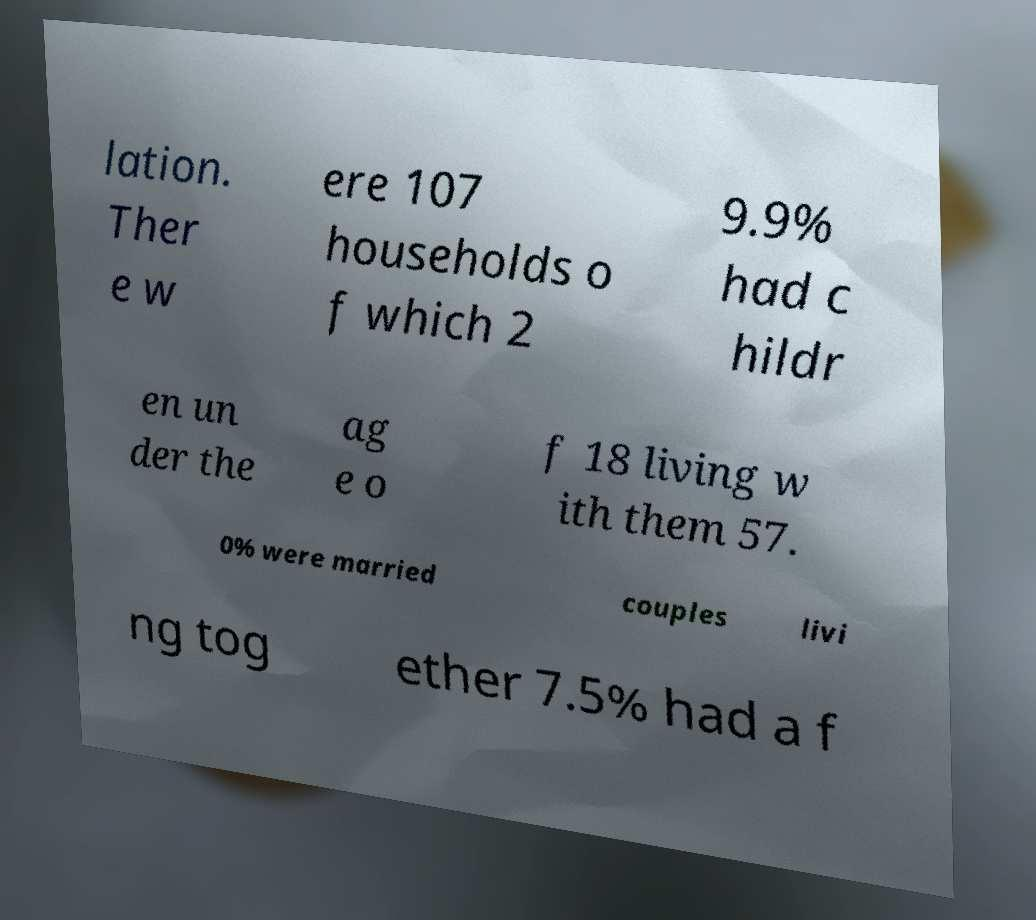Please identify and transcribe the text found in this image. lation. Ther e w ere 107 households o f which 2 9.9% had c hildr en un der the ag e o f 18 living w ith them 57. 0% were married couples livi ng tog ether 7.5% had a f 